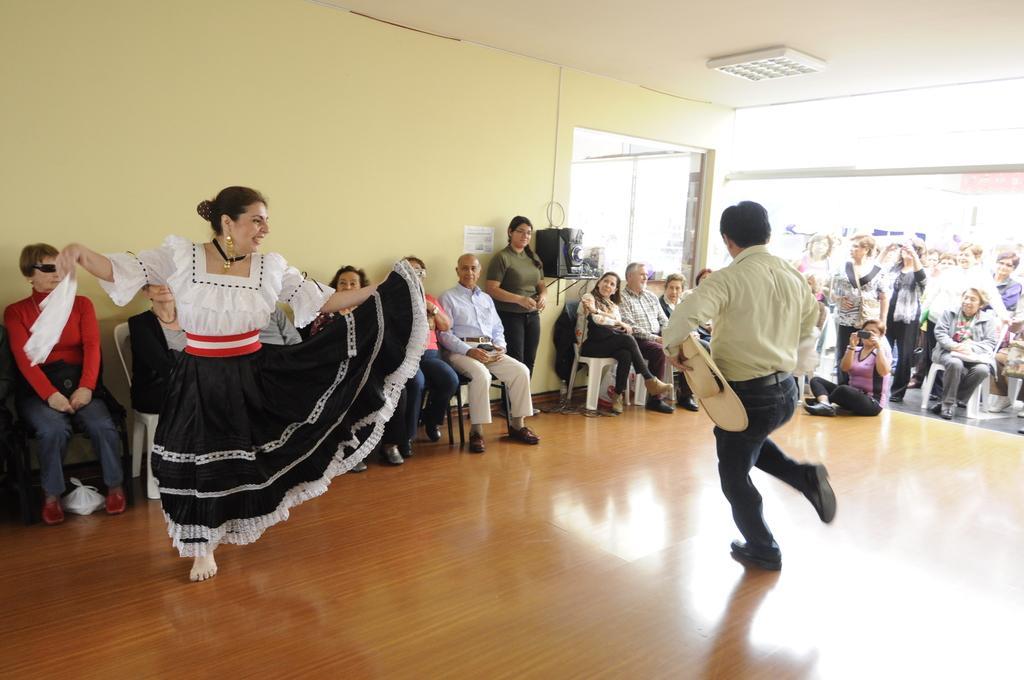Please provide a concise description of this image. In this image, we can see persons wearing clothes and sitting on chairs. There are two persons dancing on the floor in front of the wall. There is a light on the ceiling which is in the top right of the image. 